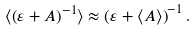<formula> <loc_0><loc_0><loc_500><loc_500>\langle \left ( \varepsilon + A \right ) ^ { - 1 } \rangle \approx \left ( \varepsilon + \langle A \rangle \right ) ^ { - 1 } .</formula> 